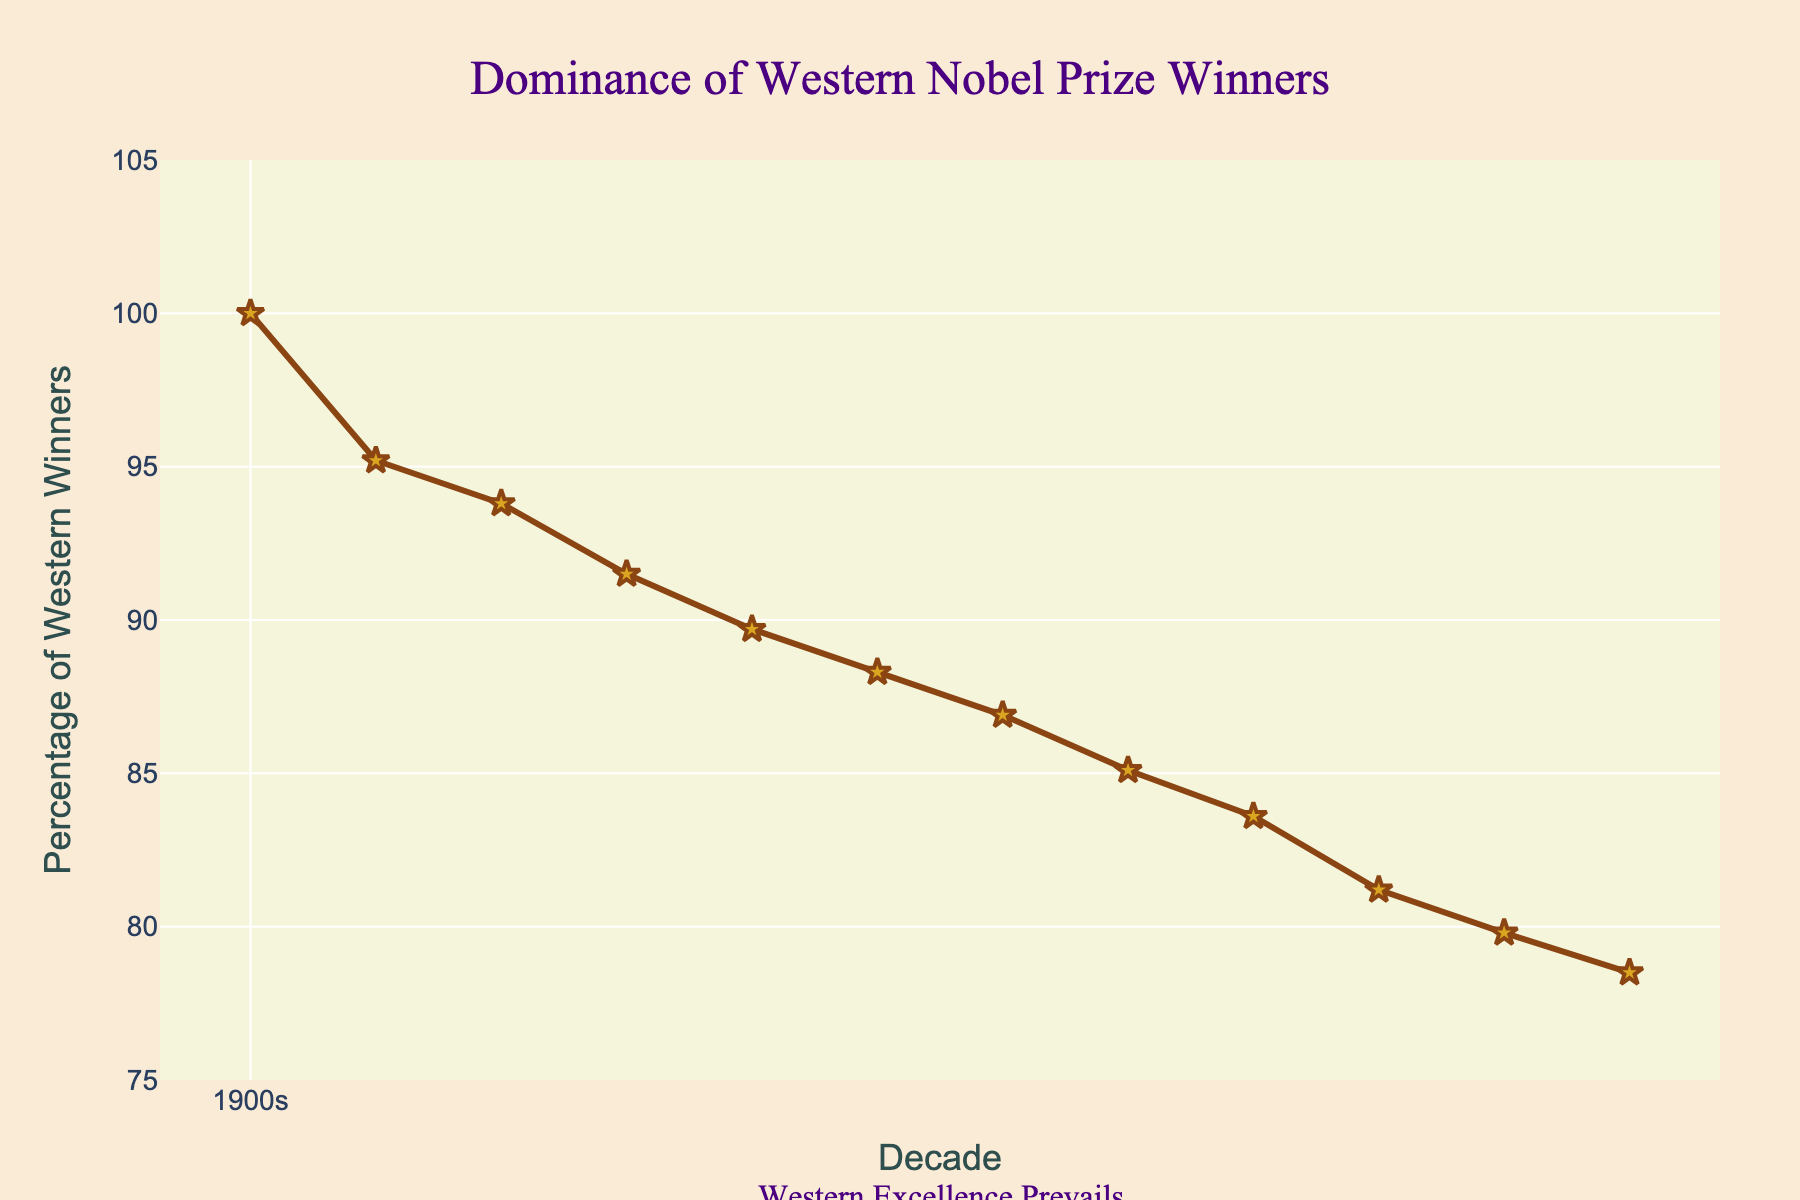What decade shows the highest percentage of Western winners? The highest percentage can be observed at the starting point of the line chart. According to the data plotted, in the 1900s, the percentage was 100%.
Answer: 1900s In which decade did the percentage of Western winners drop below 90% for the first time? From the line chart, the percentage drops below 90% starting from the 1940s, where it is 89.7%. Before that, every decade had a percentage above 90%.
Answer: 1940s What's the average percentage of Western winners over the first five decades (1900s to 1940s)? The percentages for the first five decades are 100, 95.2, 93.8, 91.5, and 89.7. Averaging these: (100 + 95.2 + 93.8 + 91.5 + 89.7) / 5 = 94.04.
Answer: 94.04 How does the percentage of Western winners in the 2010s compare to that in the 1920s? The percent in the 1920s is 93.8 and in the 2010s is 78.5. 93.8 is greater than 78.5.
Answer: Greater in 1920s Did the percentage of Western winners decrease steadily or were there any decades with an increase? By examining the plotted line, the percentage decreases continuously without any observable increase in any decade.
Answer: Decrease steadily What is the total drop in the percentage of Western winners from 1900s to 2010s? From 100% in 1900s to 78.5% in 2010s. The total drop is 100 - 78.5 = 21.5%.
Answer: 21.5% Which decade had the smallest percentage decrease compared to its previous decade? The smallest decrease appears between the 2000s and 2010s, where the change is 79.8 - 78.5 = 1.3%.
Answer: 2000s to 2010s What is the median percentage of Western winners over the recorded decades? Listing the percentages: 100, 95.2, 93.8, 91.5, 89.7, 88.3, 86.9, 85.1, 83.6, 81.2, 79.8, 78.5. The median is the average of the 6th and 7th values: (88.3 + 86.9) / 2 = 87.6%.
Answer: 87.6% What visual elements highlight the title of the figure? The title is centrally positioned and uses a larger, distinctive font in Times New Roman, with the text color in indigo, which makes it stand out.
Answer: Title font and color By how many percentage points did the winners' percentage drop from the 1900s to the 1950s? The percentage dropped from 100 in the 1900s to 88.3 in the 1950s. The difference is 100 - 88.3 = 11.7 percentage points.
Answer: 11.7 